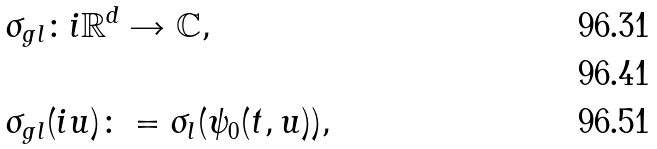<formula> <loc_0><loc_0><loc_500><loc_500>& \sigma _ { g l } \colon i { \mathbb { R } } ^ { d } \rightarrow { \mathbb { C } } , \\ \\ & \sigma _ { g l } ( i u ) \colon = \sigma _ { l } ( \psi _ { 0 } ( t , u ) ) ,</formula> 